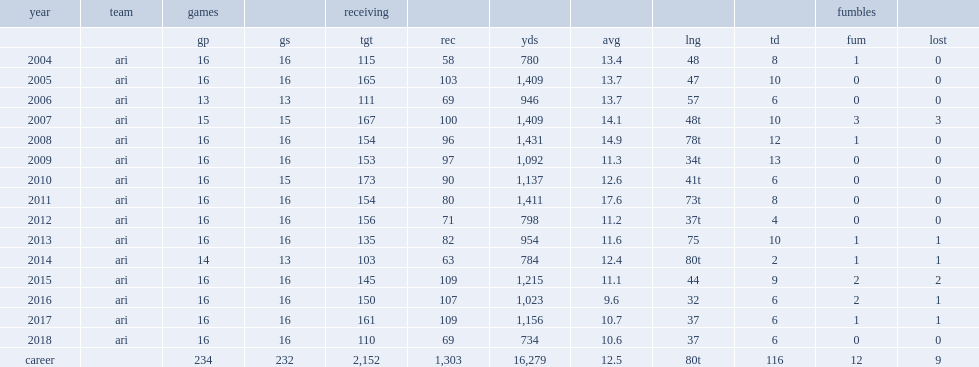When did fitzgerald catch 90 passes for 1,137 yards and six touchdowns? 2010.0. How many receptions did larry fitzgerald get in 2014? 63.0. 